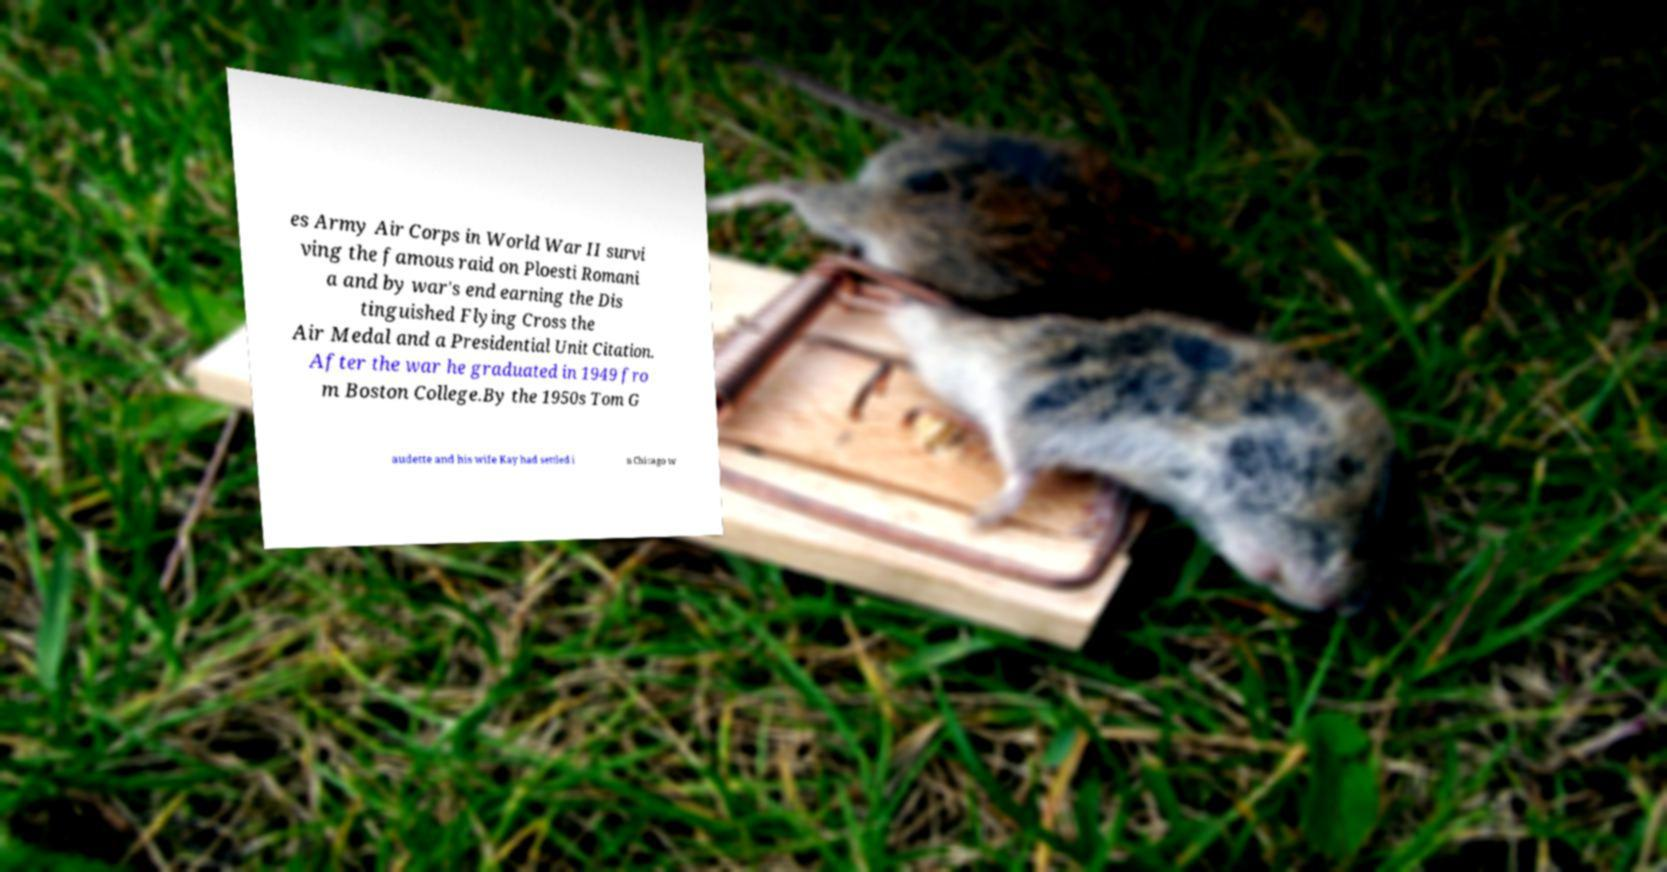I need the written content from this picture converted into text. Can you do that? es Army Air Corps in World War II survi ving the famous raid on Ploesti Romani a and by war's end earning the Dis tinguished Flying Cross the Air Medal and a Presidential Unit Citation. After the war he graduated in 1949 fro m Boston College.By the 1950s Tom G audette and his wife Kay had settled i n Chicago w 